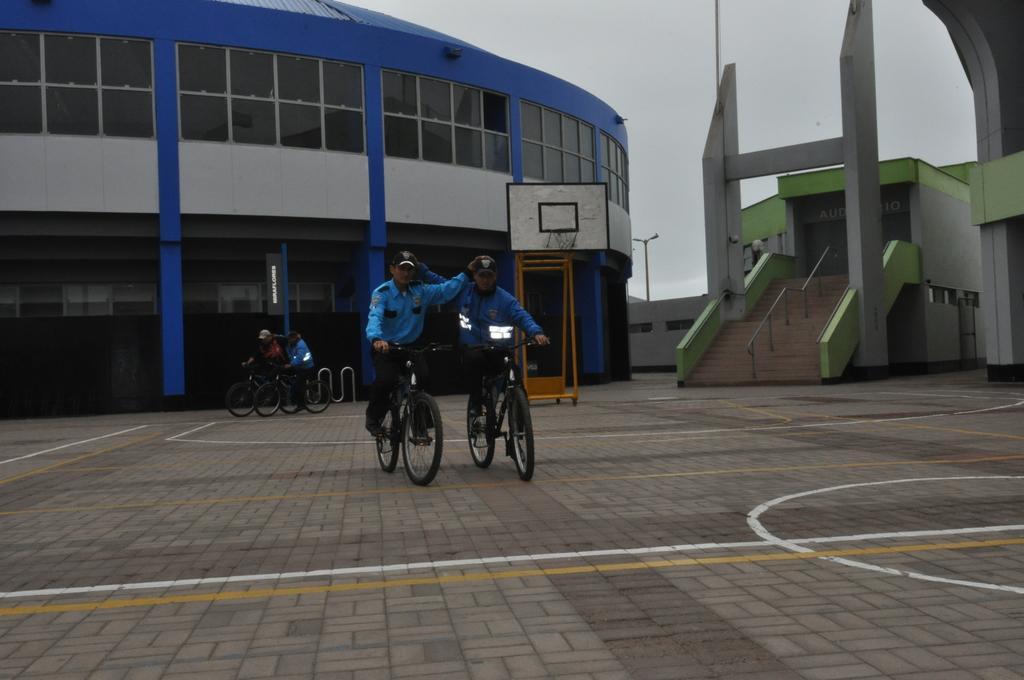In one or two sentences, can you explain what this image depicts? This is an outside view. Here I can see four people are riding their bicycles on the ground. In the background there are two buildings and also I can see a pole. To the right side building I can see the stairs at the bottom of it. On the top of the image I can see the sky. 